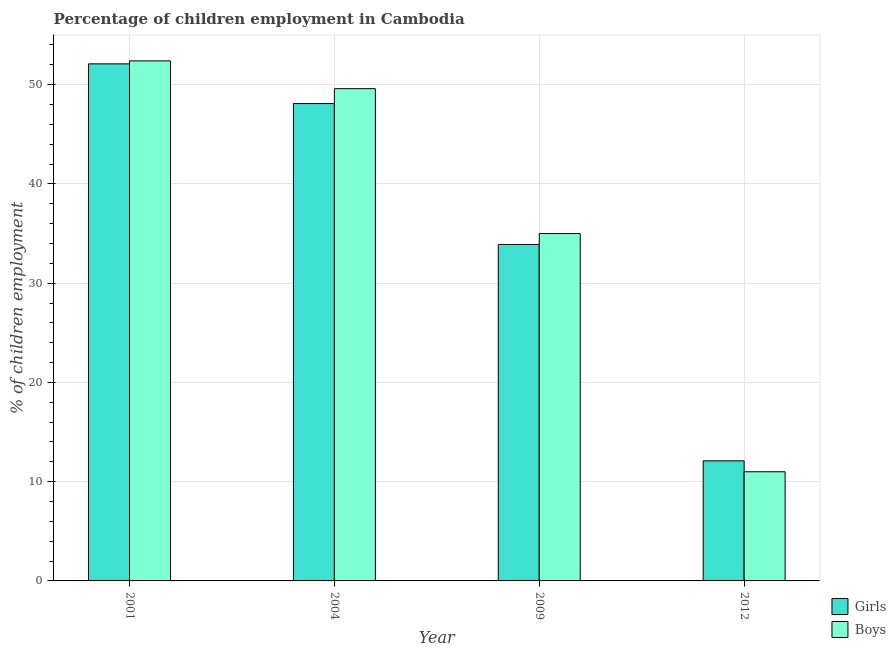How many different coloured bars are there?
Offer a very short reply. 2. How many groups of bars are there?
Ensure brevity in your answer.  4. How many bars are there on the 1st tick from the left?
Give a very brief answer. 2. What is the label of the 1st group of bars from the left?
Ensure brevity in your answer.  2001. What is the percentage of employed girls in 2012?
Your response must be concise. 12.1. Across all years, what is the maximum percentage of employed boys?
Keep it short and to the point. 52.4. Across all years, what is the minimum percentage of employed girls?
Offer a very short reply. 12.1. In which year was the percentage of employed girls maximum?
Your response must be concise. 2001. In which year was the percentage of employed girls minimum?
Your answer should be compact. 2012. What is the total percentage of employed girls in the graph?
Your answer should be compact. 146.2. What is the difference between the percentage of employed boys in 2009 and the percentage of employed girls in 2004?
Offer a terse response. -14.6. In the year 2012, what is the difference between the percentage of employed girls and percentage of employed boys?
Ensure brevity in your answer.  0. In how many years, is the percentage of employed boys greater than 28 %?
Offer a terse response. 3. What is the ratio of the percentage of employed boys in 2009 to that in 2012?
Provide a short and direct response. 3.18. What is the difference between the highest and the second highest percentage of employed boys?
Make the answer very short. 2.8. Is the sum of the percentage of employed girls in 2009 and 2012 greater than the maximum percentage of employed boys across all years?
Provide a succinct answer. No. What does the 2nd bar from the left in 2004 represents?
Offer a terse response. Boys. What does the 1st bar from the right in 2004 represents?
Offer a terse response. Boys. How many bars are there?
Provide a succinct answer. 8. How many years are there in the graph?
Provide a succinct answer. 4. What is the difference between two consecutive major ticks on the Y-axis?
Give a very brief answer. 10. Are the values on the major ticks of Y-axis written in scientific E-notation?
Your answer should be very brief. No. Does the graph contain any zero values?
Your answer should be very brief. No. Does the graph contain grids?
Your answer should be very brief. Yes. How many legend labels are there?
Ensure brevity in your answer.  2. What is the title of the graph?
Provide a short and direct response. Percentage of children employment in Cambodia. Does "Borrowers" appear as one of the legend labels in the graph?
Provide a short and direct response. No. What is the label or title of the Y-axis?
Make the answer very short. % of children employment. What is the % of children employment of Girls in 2001?
Ensure brevity in your answer.  52.1. What is the % of children employment in Boys in 2001?
Give a very brief answer. 52.4. What is the % of children employment of Girls in 2004?
Give a very brief answer. 48.1. What is the % of children employment in Boys in 2004?
Offer a terse response. 49.6. What is the % of children employment in Girls in 2009?
Provide a short and direct response. 33.9. What is the % of children employment of Boys in 2009?
Keep it short and to the point. 35. What is the % of children employment in Boys in 2012?
Ensure brevity in your answer.  11. Across all years, what is the maximum % of children employment of Girls?
Ensure brevity in your answer.  52.1. Across all years, what is the maximum % of children employment in Boys?
Keep it short and to the point. 52.4. Across all years, what is the minimum % of children employment of Girls?
Offer a terse response. 12.1. Across all years, what is the minimum % of children employment of Boys?
Provide a succinct answer. 11. What is the total % of children employment of Girls in the graph?
Your answer should be compact. 146.2. What is the total % of children employment of Boys in the graph?
Ensure brevity in your answer.  148. What is the difference between the % of children employment of Girls in 2001 and that in 2009?
Your response must be concise. 18.2. What is the difference between the % of children employment of Boys in 2001 and that in 2009?
Provide a short and direct response. 17.4. What is the difference between the % of children employment of Girls in 2001 and that in 2012?
Provide a succinct answer. 40. What is the difference between the % of children employment in Boys in 2001 and that in 2012?
Your answer should be compact. 41.4. What is the difference between the % of children employment in Girls in 2004 and that in 2009?
Provide a short and direct response. 14.2. What is the difference between the % of children employment in Boys in 2004 and that in 2009?
Your answer should be compact. 14.6. What is the difference between the % of children employment in Girls in 2004 and that in 2012?
Ensure brevity in your answer.  36. What is the difference between the % of children employment of Boys in 2004 and that in 2012?
Make the answer very short. 38.6. What is the difference between the % of children employment in Girls in 2009 and that in 2012?
Offer a terse response. 21.8. What is the difference between the % of children employment of Girls in 2001 and the % of children employment of Boys in 2004?
Keep it short and to the point. 2.5. What is the difference between the % of children employment in Girls in 2001 and the % of children employment in Boys in 2012?
Your response must be concise. 41.1. What is the difference between the % of children employment in Girls in 2004 and the % of children employment in Boys in 2012?
Provide a short and direct response. 37.1. What is the difference between the % of children employment of Girls in 2009 and the % of children employment of Boys in 2012?
Provide a short and direct response. 22.9. What is the average % of children employment of Girls per year?
Offer a very short reply. 36.55. In the year 2001, what is the difference between the % of children employment in Girls and % of children employment in Boys?
Offer a very short reply. -0.3. In the year 2009, what is the difference between the % of children employment of Girls and % of children employment of Boys?
Provide a succinct answer. -1.1. What is the ratio of the % of children employment in Girls in 2001 to that in 2004?
Your answer should be very brief. 1.08. What is the ratio of the % of children employment of Boys in 2001 to that in 2004?
Offer a very short reply. 1.06. What is the ratio of the % of children employment in Girls in 2001 to that in 2009?
Give a very brief answer. 1.54. What is the ratio of the % of children employment in Boys in 2001 to that in 2009?
Your answer should be very brief. 1.5. What is the ratio of the % of children employment of Girls in 2001 to that in 2012?
Your answer should be compact. 4.31. What is the ratio of the % of children employment of Boys in 2001 to that in 2012?
Your answer should be compact. 4.76. What is the ratio of the % of children employment in Girls in 2004 to that in 2009?
Give a very brief answer. 1.42. What is the ratio of the % of children employment in Boys in 2004 to that in 2009?
Provide a short and direct response. 1.42. What is the ratio of the % of children employment in Girls in 2004 to that in 2012?
Your answer should be very brief. 3.98. What is the ratio of the % of children employment of Boys in 2004 to that in 2012?
Keep it short and to the point. 4.51. What is the ratio of the % of children employment of Girls in 2009 to that in 2012?
Ensure brevity in your answer.  2.8. What is the ratio of the % of children employment of Boys in 2009 to that in 2012?
Provide a short and direct response. 3.18. What is the difference between the highest and the second highest % of children employment of Girls?
Offer a very short reply. 4. What is the difference between the highest and the second highest % of children employment of Boys?
Make the answer very short. 2.8. What is the difference between the highest and the lowest % of children employment of Boys?
Your answer should be compact. 41.4. 